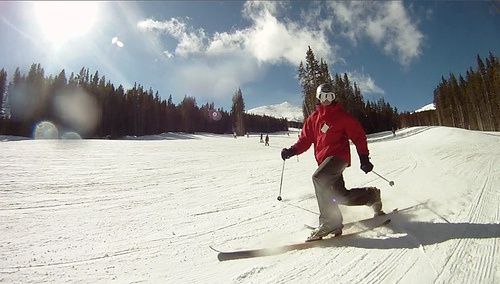Describe the objects in this image and their specific colors. I can see people in gray, maroon, black, and brown tones, skis in gray, beige, darkgray, and lightgray tones, people in gray and black tones, people in gray, black, maroon, and darkgray tones, and people in gray, darkgray, and black tones in this image. 